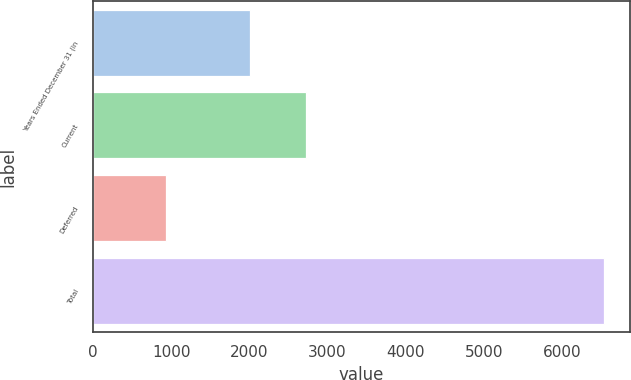<chart> <loc_0><loc_0><loc_500><loc_500><bar_chart><fcel>Years Ended December 31 (in<fcel>Current<fcel>Deferred<fcel>Total<nl><fcel>2006<fcel>2725<fcel>933<fcel>6537<nl></chart> 